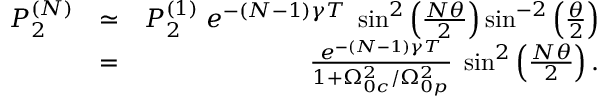Convert formula to latex. <formula><loc_0><loc_0><loc_500><loc_500>\begin{array} { r l r } { P _ { 2 } ^ { ( N ) } } & { \simeq } & { P _ { 2 } ^ { ( 1 ) } \, e ^ { - ( N - 1 ) \gamma T } \, \sin ^ { 2 } \left ( \frac { N \theta } { 2 } \right ) \sin ^ { - 2 } \left ( \frac { \theta } { 2 } \right ) } \\ & { = } & { \frac { e ^ { - ( N - 1 ) \gamma T } } { 1 + \Omega _ { 0 c } ^ { 2 } / \Omega _ { 0 p } ^ { 2 } } \, \sin ^ { 2 } \left ( \frac { N \theta } { 2 } \right ) . } \end{array}</formula> 